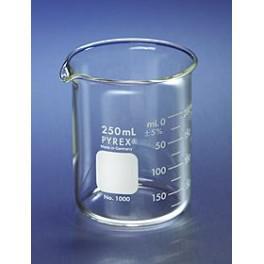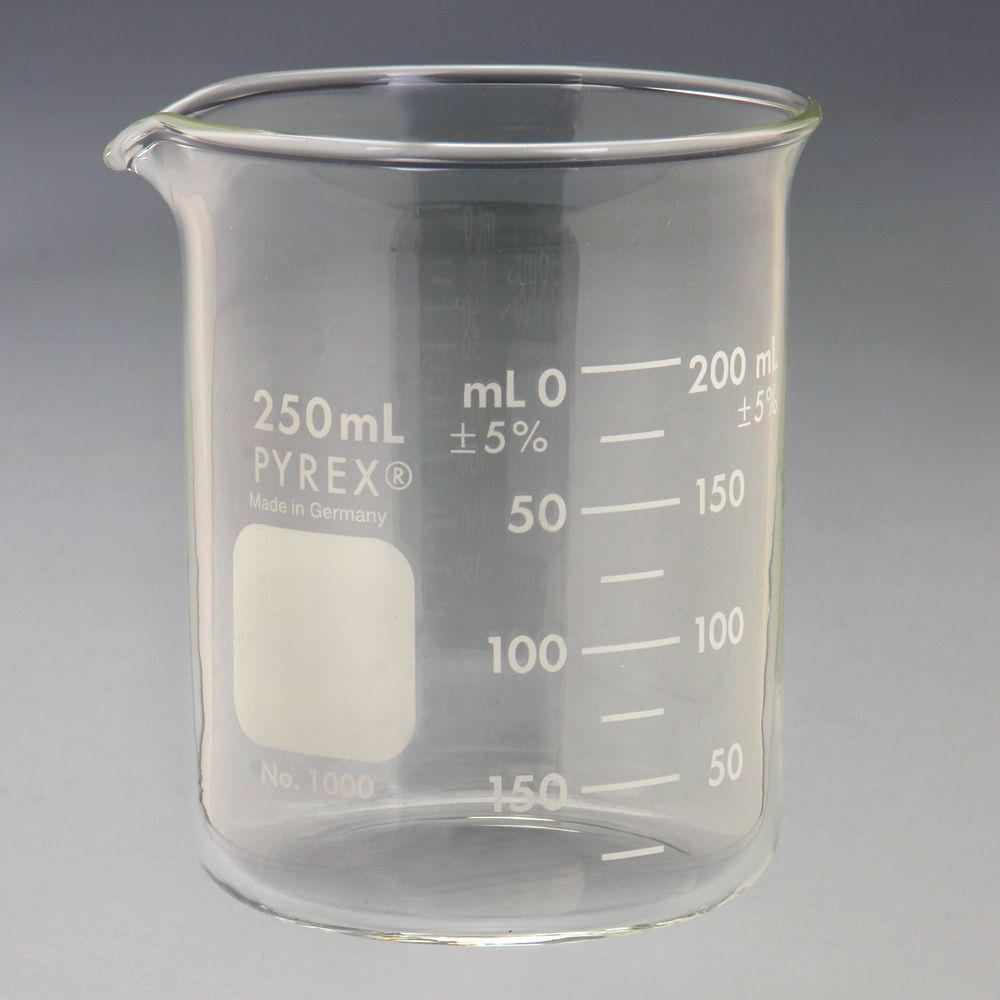The first image is the image on the left, the second image is the image on the right. For the images displayed, is the sentence "there is red liquid in a glass beaker" factually correct? Answer yes or no. No. The first image is the image on the left, the second image is the image on the right. Given the left and right images, does the statement "There is no less than one clear beaker with red liquid in it" hold true? Answer yes or no. No. 